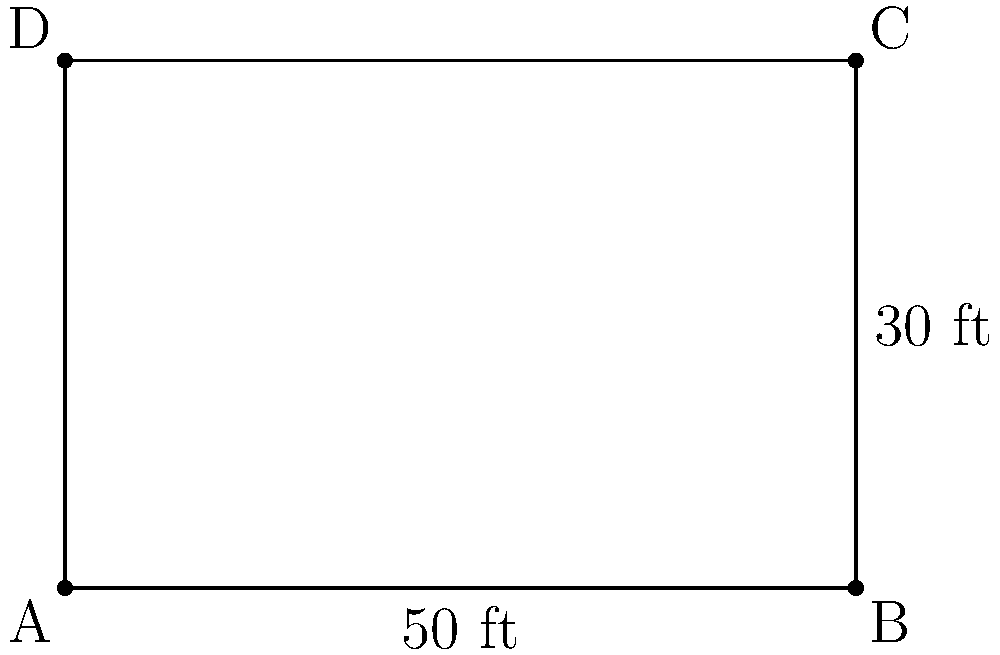You're planning to fence the rectangular playground at your child's preschool. The playground measures 50 feet in length and 30 feet in width. How many feet of fencing material will you need to completely enclose the playground? To solve this problem, we need to calculate the perimeter of the rectangular playground. The perimeter is the distance around the entire shape. For a rectangle, we can use the formula:

$$ P = 2l + 2w $$

Where:
$P$ = perimeter
$l$ = length
$w$ = width

Given:
Length ($l$) = 50 feet
Width ($w$) = 30 feet

Let's substitute these values into the formula:

$$ P = 2(50) + 2(30) $$
$$ P = 100 + 60 $$
$$ P = 160 $$

Therefore, you will need 160 feet of fencing material to completely enclose the playground.
Answer: 160 feet 